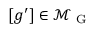<formula> <loc_0><loc_0><loc_500><loc_500>[ g ^ { \prime } ] \in \mathcal { M } _ { G }</formula> 